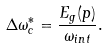Convert formula to latex. <formula><loc_0><loc_0><loc_500><loc_500>\Delta \omega _ { c } ^ { * } = \frac { E _ { g } ( p ) } { \omega _ { i n t } } .</formula> 